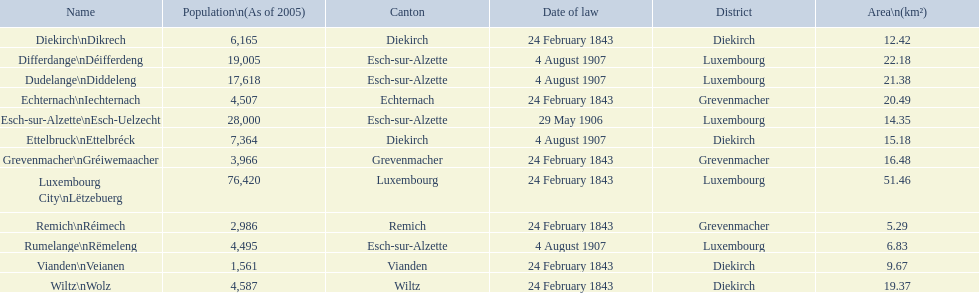Which canton falls under the date of law of 24 february 1843 and has a population of 3,966? Grevenmacher. 